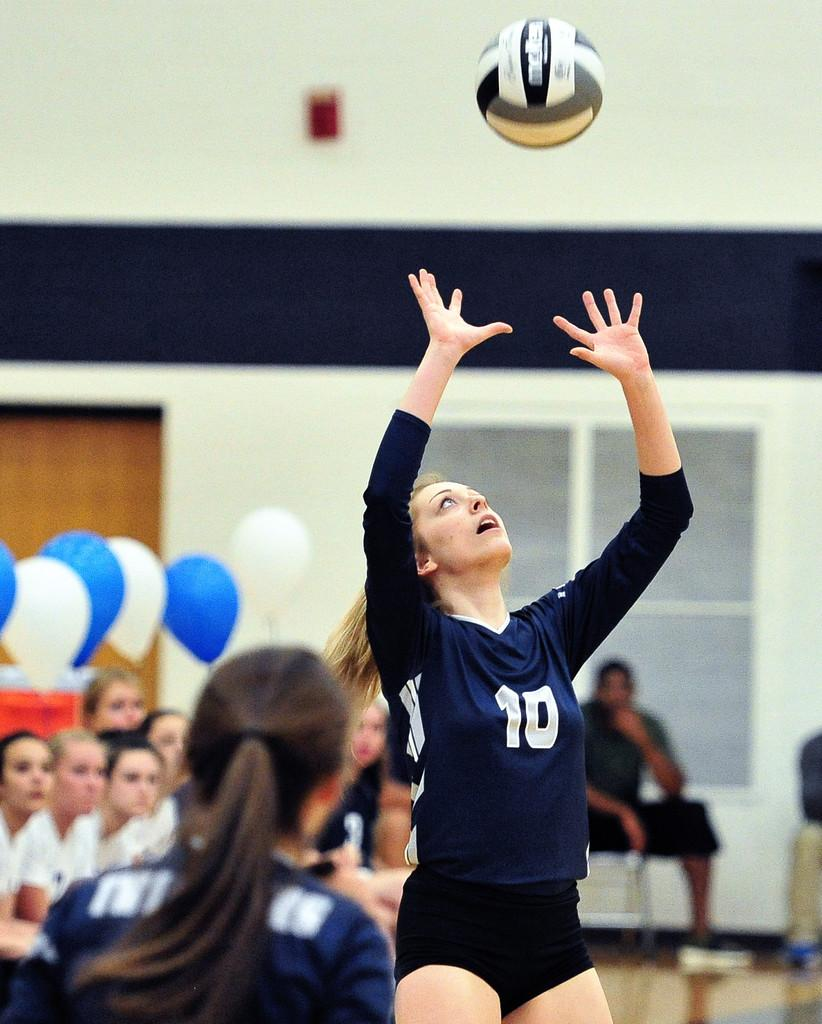How many women are in the image? There are two women in the image. What is happening with the ball in the image? A ball is in the air. What can be seen in the background of the image? There are balloons, a window, a wall, a group of people sitting on chairs, and other objects visible in the background of the image. What type of butter is being used for writing in the image? There is no butter or writing present in the image. 